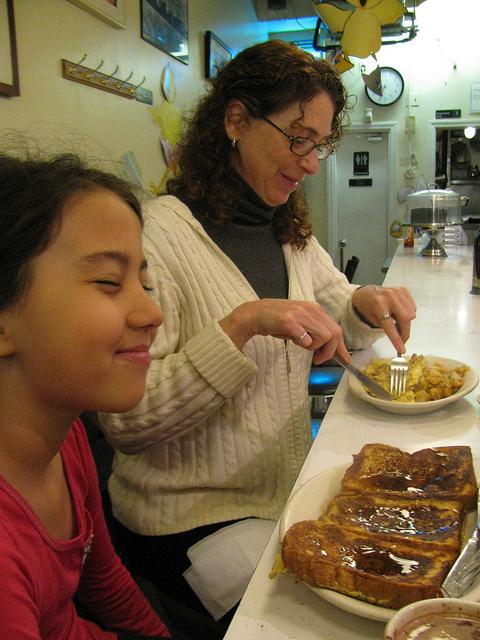What color is the plate?
Be succinct. White. Did the woman just start eating?
Be succinct. Yes. Who is holding the silverware?
Concise answer only. Woman. Where is the silver wear?
Keep it brief. In woman's hands. What is the woman doing with the knife and fork?
Write a very short answer. Cutting food. 